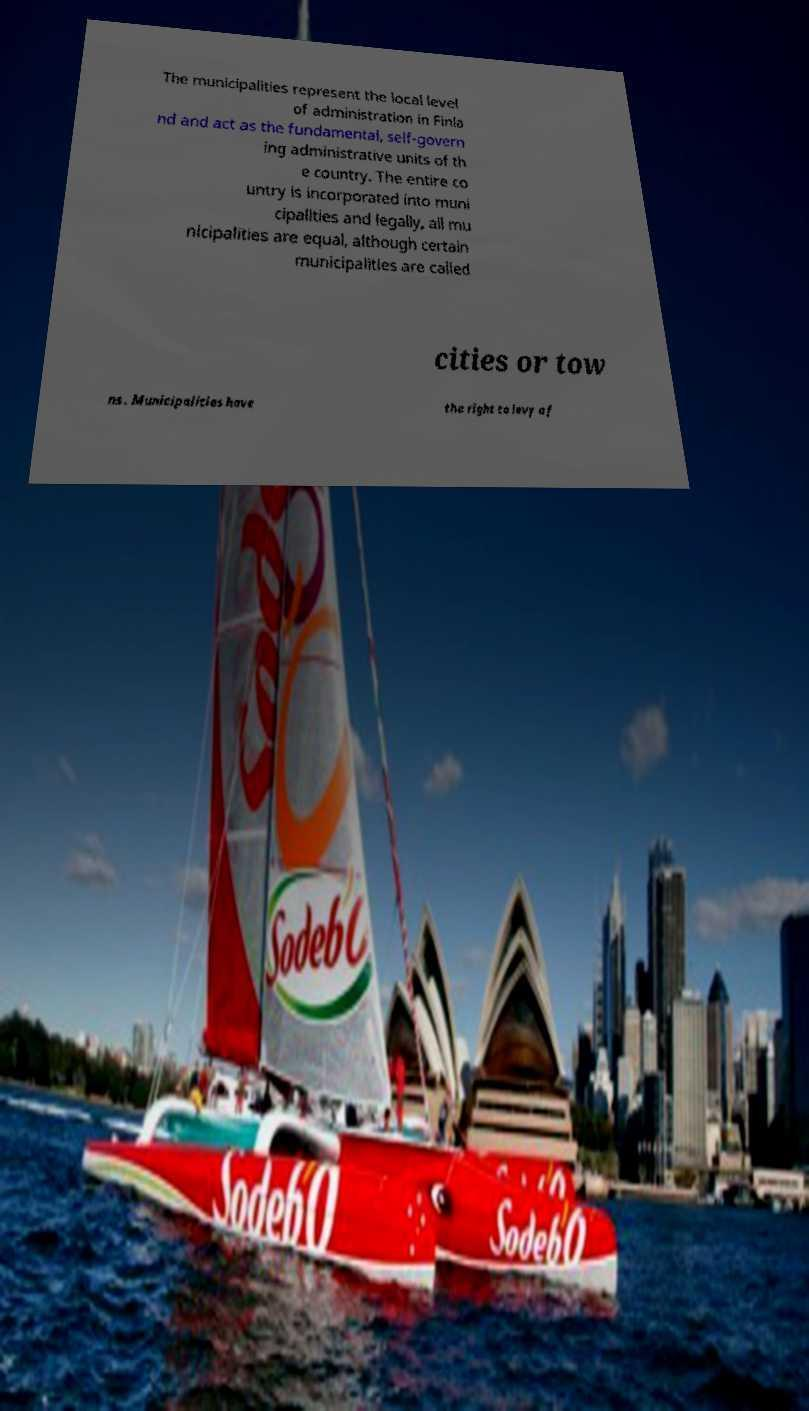Please identify and transcribe the text found in this image. The municipalities represent the local level of administration in Finla nd and act as the fundamental, self-govern ing administrative units of th e country. The entire co untry is incorporated into muni cipalities and legally, all mu nicipalities are equal, although certain municipalities are called cities or tow ns . Municipalities have the right to levy a f 